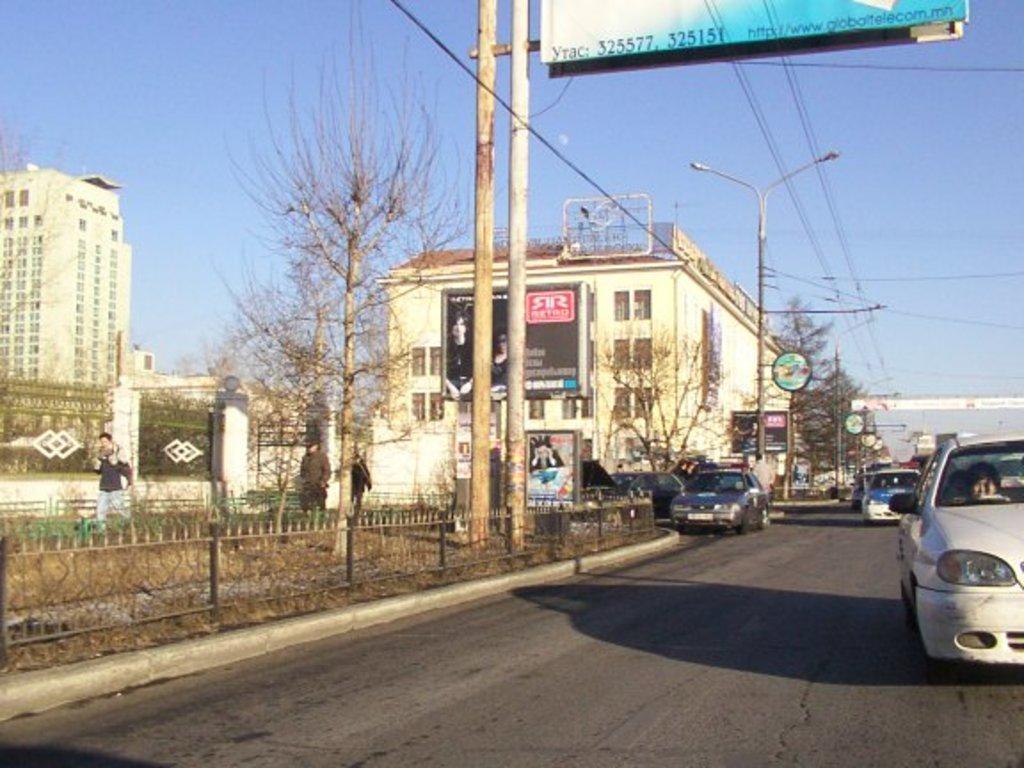Could you give a brief overview of what you see in this image? In this image we can see a few people, there are vehicles on the road, one person is driving a car, there are light poles, there are boards with text on them, there are buildings, railings, trees, plants, also we can see the sky. 